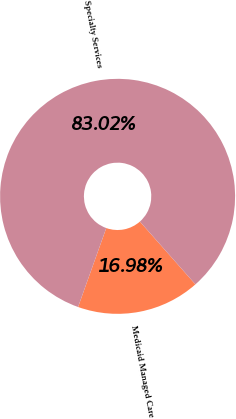Convert chart to OTSL. <chart><loc_0><loc_0><loc_500><loc_500><pie_chart><fcel>Medicaid Managed Care<fcel>Specialty Services<nl><fcel>16.98%<fcel>83.02%<nl></chart> 